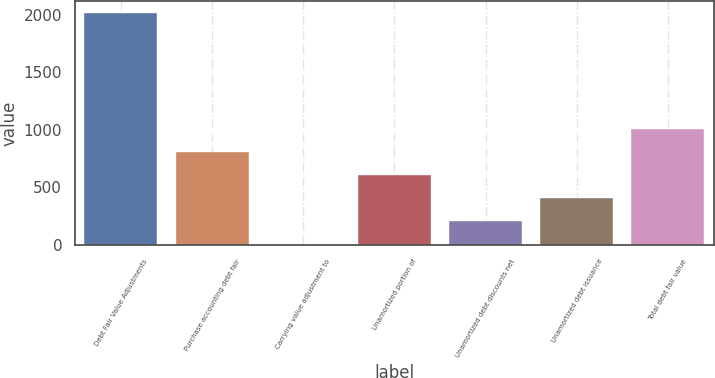Convert chart to OTSL. <chart><loc_0><loc_0><loc_500><loc_500><bar_chart><fcel>Debt Fair Value Adjustments<fcel>Purchase accounting debt fair<fcel>Carrying value adjustment to<fcel>Unamortized portion of<fcel>Unamortized debt discounts net<fcel>Unamortized debt issuance<fcel>Total debt fair value<nl><fcel>2018<fcel>808.4<fcel>2<fcel>606.8<fcel>203.6<fcel>405.2<fcel>1010<nl></chart> 